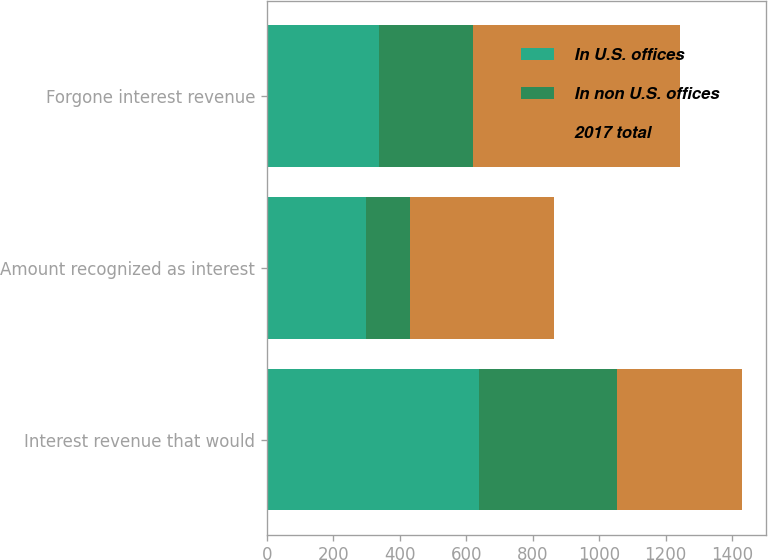Convert chart. <chart><loc_0><loc_0><loc_500><loc_500><stacked_bar_chart><ecel><fcel>Interest revenue that would<fcel>Amount recognized as interest<fcel>Forgone interest revenue<nl><fcel>In U.S. offices<fcel>637<fcel>299<fcel>338<nl><fcel>In non U.S. offices<fcel>416<fcel>133<fcel>283<nl><fcel>2017 total<fcel>377<fcel>432<fcel>621<nl></chart> 